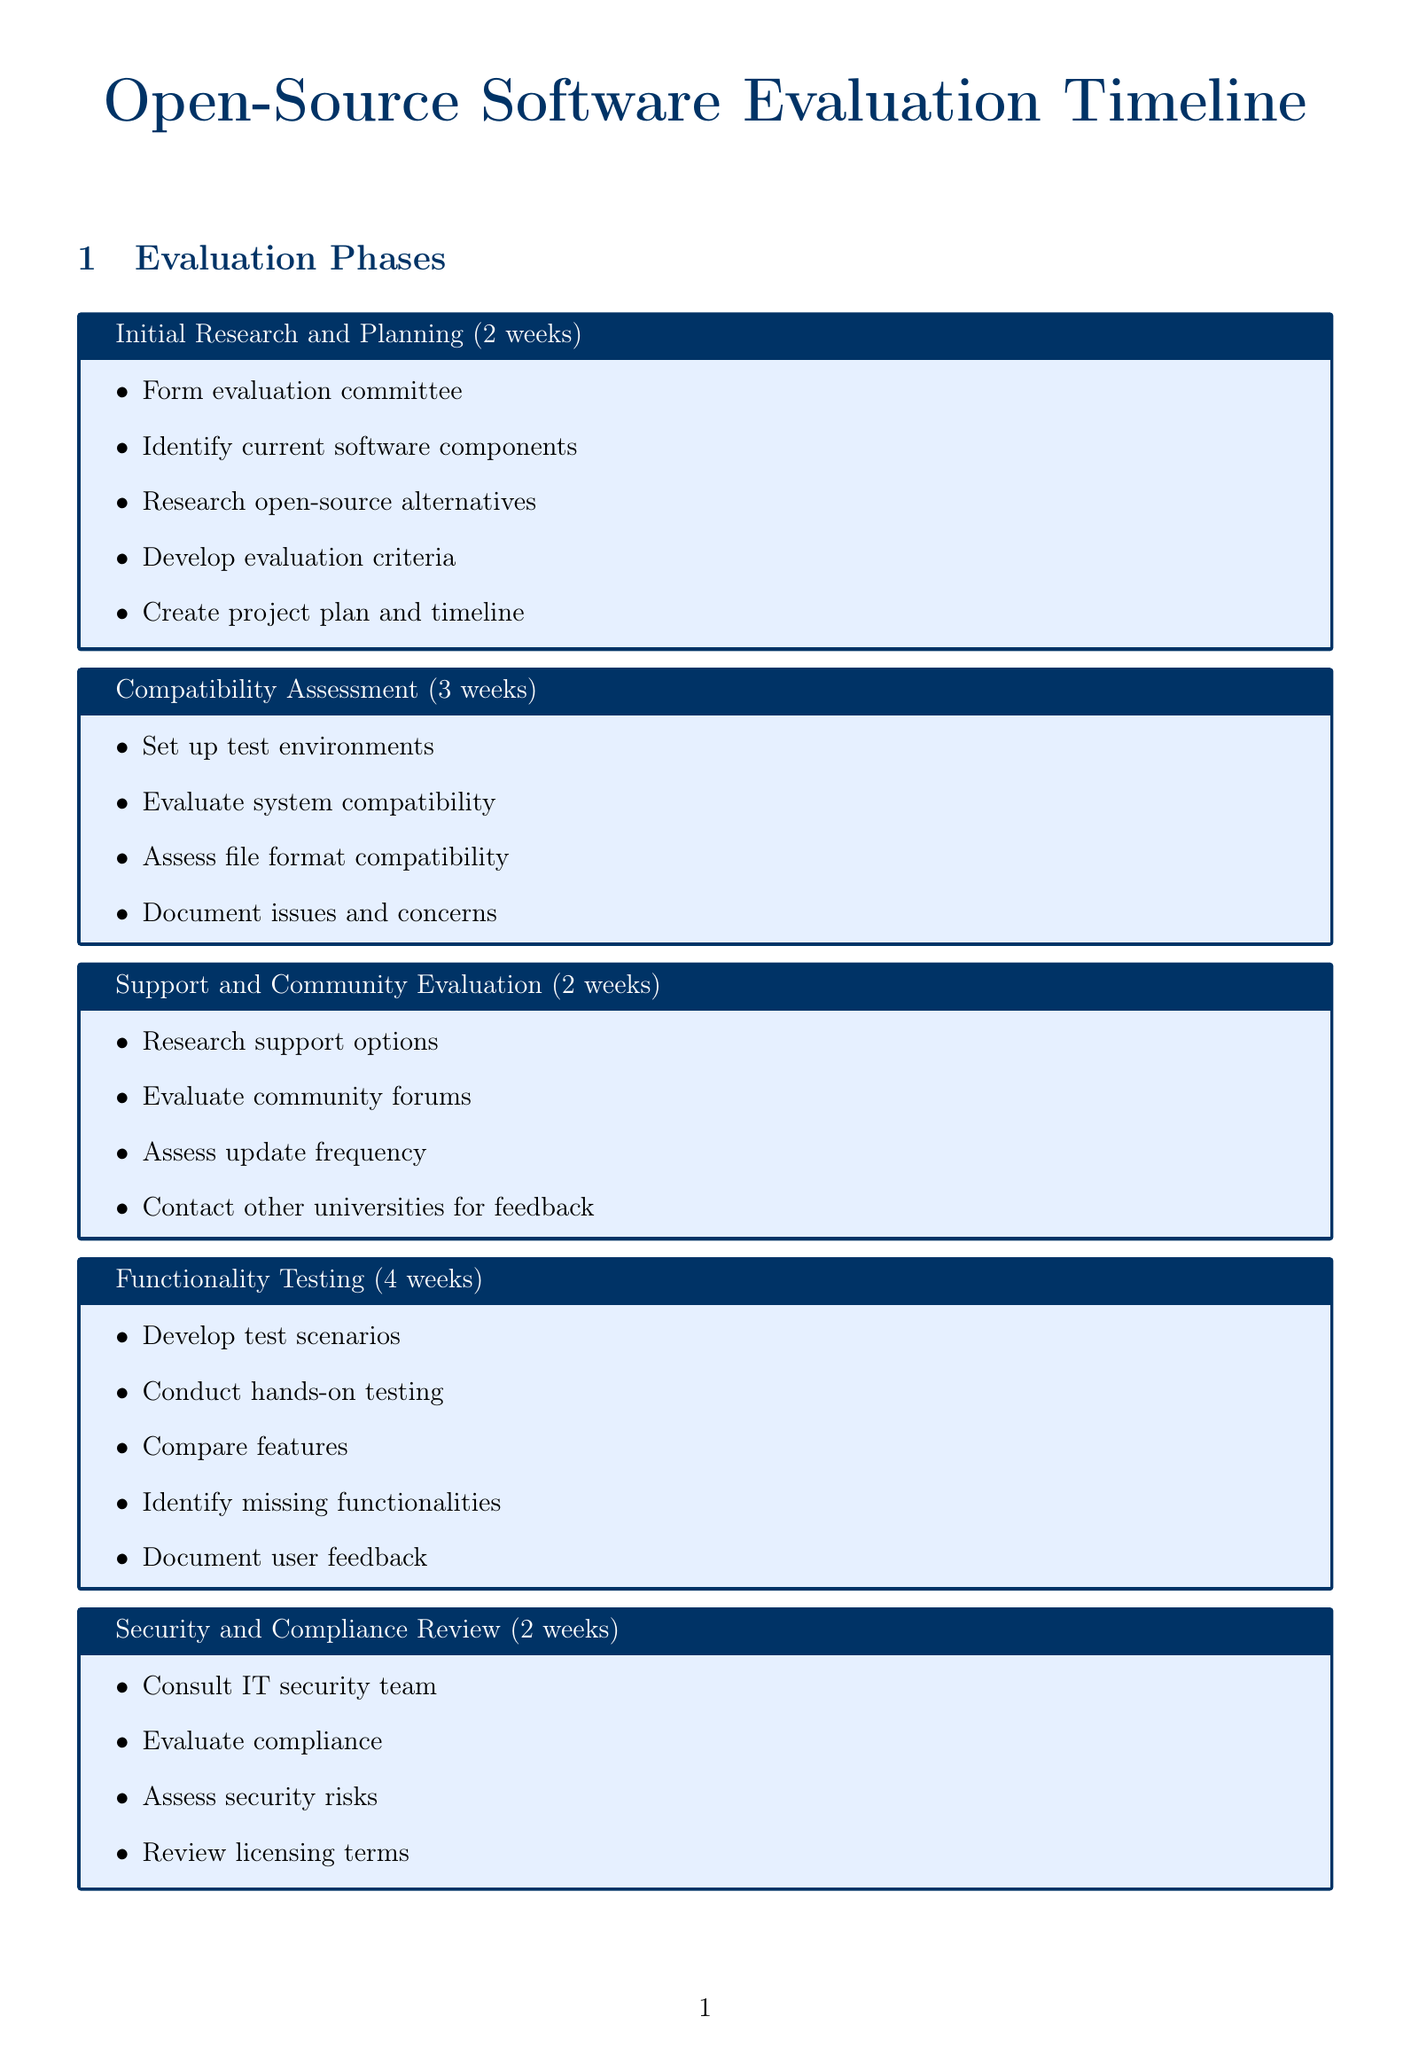What is the duration of the Initial Research and Planning phase? The duration of the Initial Research and Planning phase is mentioned in the document as 2 weeks.
Answer: 2 weeks Who is the IT Services Manager involved in the evaluation? The document lists key stakeholders, including Lisa Rodriguez as the IT Services Manager.
Answer: Lisa Rodriguez What is the main focus of the evaluation criteria? The document provides a specific list of evaluation criteria; one of them is compatibility with existing university systems.
Answer: Compatibility with existing university systems How long is the Cost Analysis phase? The document states that the Cost Analysis phase lasts for 2 weeks.
Answer: 2 weeks Which open-source alternative is suggested for Adobe Creative Cloud? The document lists several alternatives for Adobe Creative Cloud, one of which is GIMP.
Answer: GIMP What is one task in the Security and Compliance Review phase? The document outlines tasks, including consulting with the university IT security team as part of the Security and Compliance Review.
Answer: Consult IT security team What is the total duration of the Functionality Testing phase? The Functionality Testing phase duration is specified as 4 weeks in the document.
Answer: 4 weeks How many stakeholders are listed in the document? The document enumerates six key stakeholders involved in the evaluation process.
Answer: Six What is the last phase mentioned in the schedule? The document lists the Final Evaluation and Recommendation phase as the last phase in the schedule.
Answer: Final Evaluation and Recommendation 